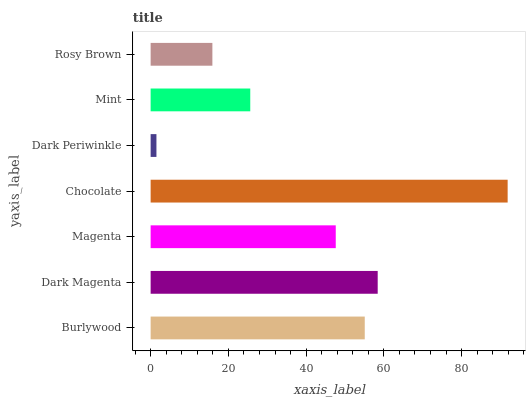Is Dark Periwinkle the minimum?
Answer yes or no. Yes. Is Chocolate the maximum?
Answer yes or no. Yes. Is Dark Magenta the minimum?
Answer yes or no. No. Is Dark Magenta the maximum?
Answer yes or no. No. Is Dark Magenta greater than Burlywood?
Answer yes or no. Yes. Is Burlywood less than Dark Magenta?
Answer yes or no. Yes. Is Burlywood greater than Dark Magenta?
Answer yes or no. No. Is Dark Magenta less than Burlywood?
Answer yes or no. No. Is Magenta the high median?
Answer yes or no. Yes. Is Magenta the low median?
Answer yes or no. Yes. Is Mint the high median?
Answer yes or no. No. Is Mint the low median?
Answer yes or no. No. 